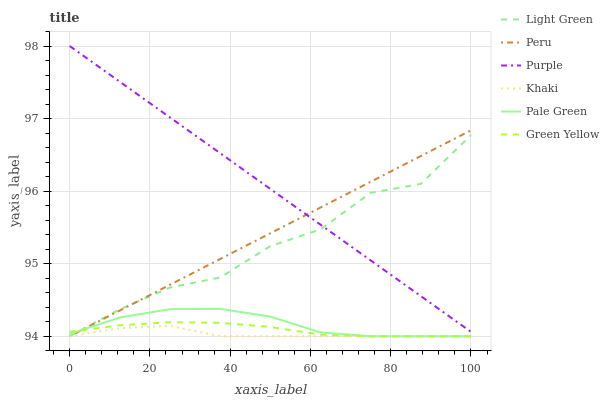Does Khaki have the minimum area under the curve?
Answer yes or no. Yes. Does Purple have the maximum area under the curve?
Answer yes or no. Yes. Does Light Green have the minimum area under the curve?
Answer yes or no. No. Does Light Green have the maximum area under the curve?
Answer yes or no. No. Is Purple the smoothest?
Answer yes or no. Yes. Is Light Green the roughest?
Answer yes or no. Yes. Is Light Green the smoothest?
Answer yes or no. No. Is Purple the roughest?
Answer yes or no. No. Does Khaki have the lowest value?
Answer yes or no. Yes. Does Purple have the lowest value?
Answer yes or no. No. Does Purple have the highest value?
Answer yes or no. Yes. Does Light Green have the highest value?
Answer yes or no. No. Is Pale Green less than Purple?
Answer yes or no. Yes. Is Purple greater than Pale Green?
Answer yes or no. Yes. Does Light Green intersect Purple?
Answer yes or no. Yes. Is Light Green less than Purple?
Answer yes or no. No. Is Light Green greater than Purple?
Answer yes or no. No. Does Pale Green intersect Purple?
Answer yes or no. No. 